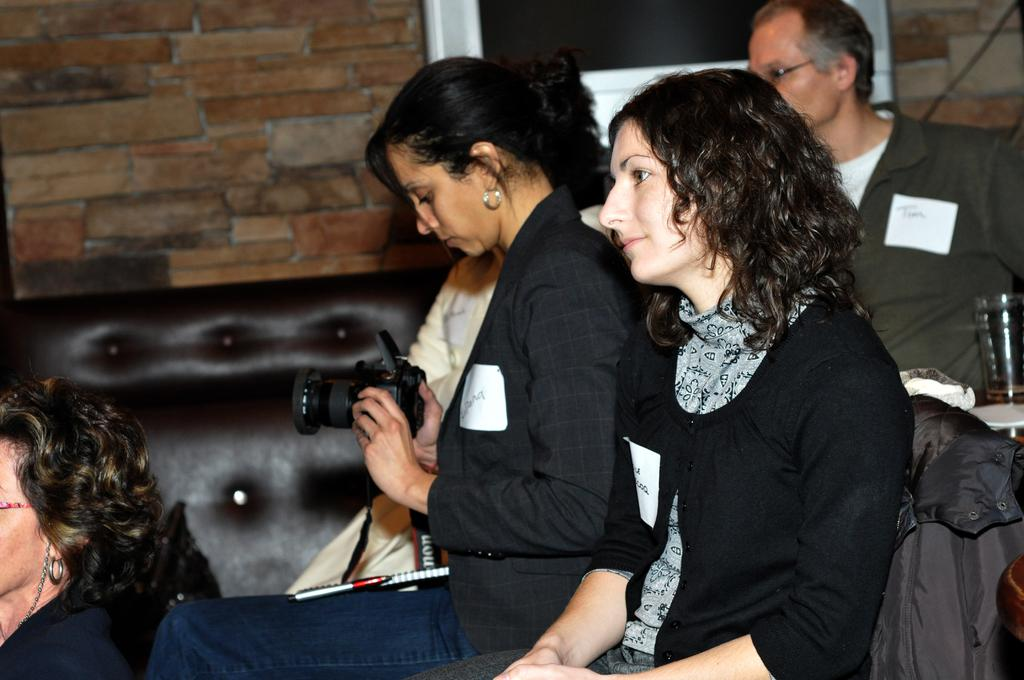How many people are in the image? There are people in the image, but the exact number is not specified. What is the woman in the image holding? The woman is holding a camera in the image. What type of object can be seen in the image that is made of glass? There is a glass object in the image. What type of furniture is present in the image? There is a sofa in the image. What can be seen in the background of the image? There is a wall visible in the background of the image. What page is the father reading in the image? There is no mention of a father or a book being read in the image. 